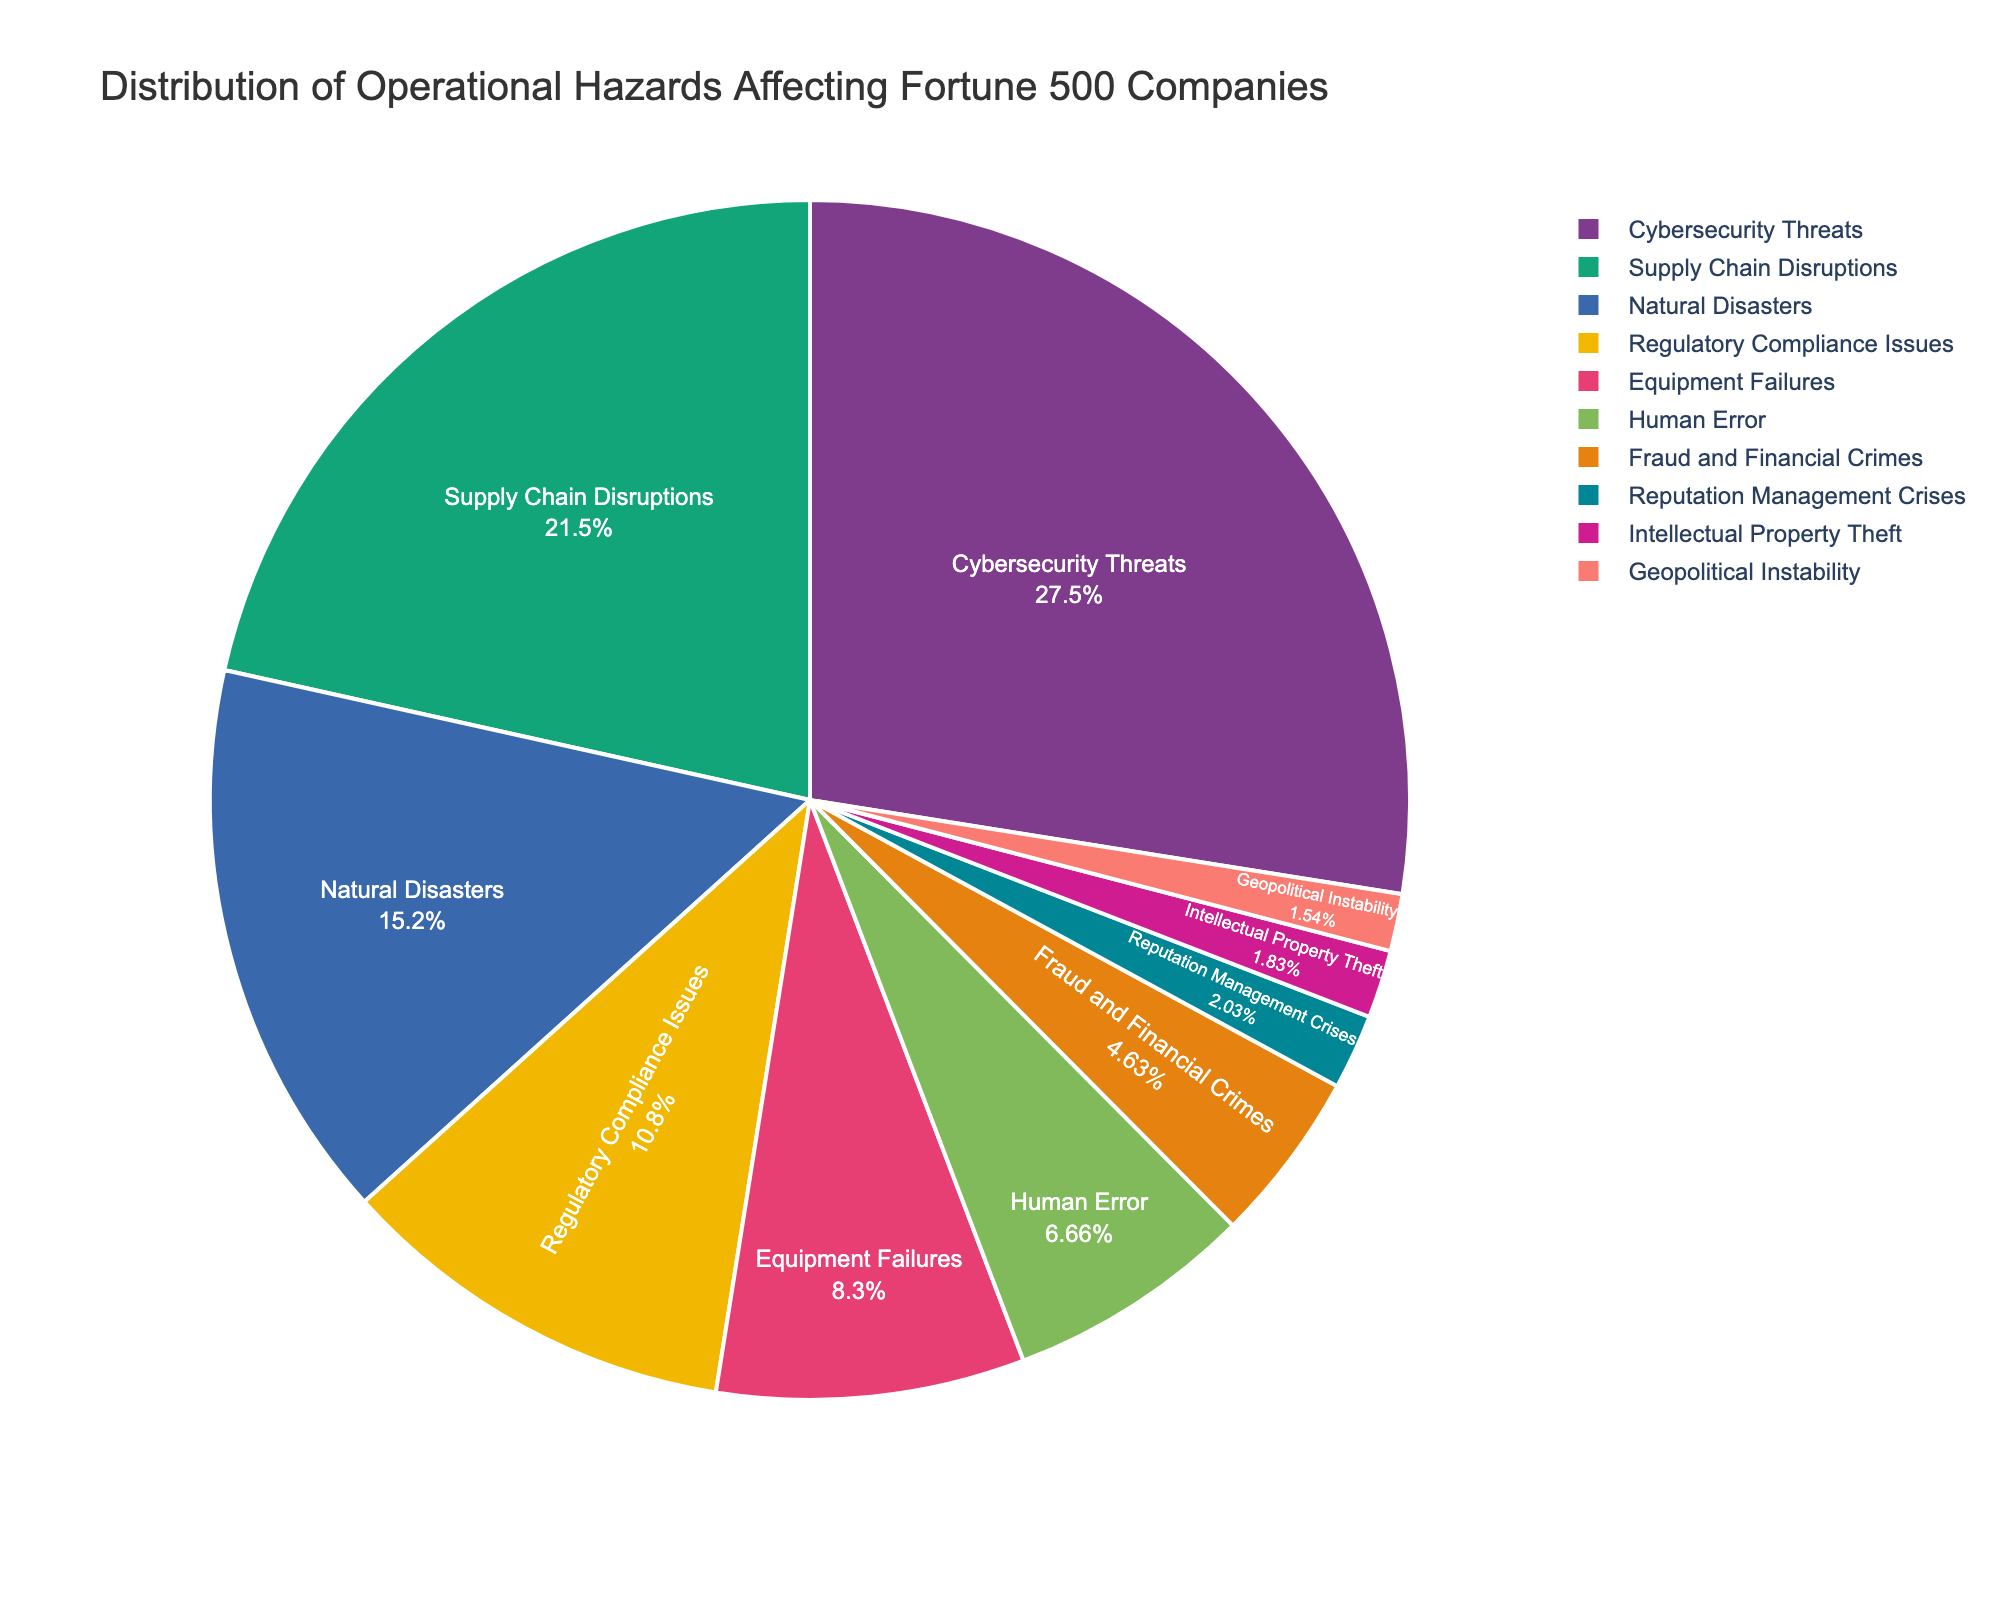What's the largest category of operational hazards? The largest category is the one with the highest percentage. According to the data, Cybersecurity Threats have the highest percentage at 28.5%.
Answer: Cybersecurity Threats Which two categories combined account for nearly half of the operational hazards? To find the categories that combined account for nearly half, we sum the percentages of the two largest categories: Cybersecurity Threats (28.5%) and Supply Chain Disruptions (22.3%). Their sum is 28.5% + 22.3% = 50.8%, which is more than half.
Answer: Cybersecurity Threats and Supply Chain Disruptions What is the percentage difference between Cybersecurity Threats and Natural Disasters? The percentage for Cybersecurity Threats is 28.5% and for Natural Disasters is 15.7%. The difference is calculated as 28.5% - 15.7% = 12.8%.
Answer: 12.8% Which category is visually the smallest on the pie chart, and what is its percentage? The smallest slice in the pie chart corresponds to the category with the smallest percentage. Geopolitical Instability has the smallest percentage at 1.6%.
Answer: Geopolitical Instability, 1.6% Between Equipment Failures and Human Error, which has a higher percentage and by how much? Equipment Failures has a percentage of 8.6% while Human Error has 6.9%. The difference is calculated as 8.6% - 6.9% = 1.7%.
Answer: Equipment Failures, 1.7% What is the combined percentage of the three least significant operational hazards? The three least significant categories are Geopolitical Instability (1.6%), Intellectual Property Theft (1.9%), and Reputation Management Crises (2.1%). The combined percentage is calculated as 1.6% + 1.9% + 2.1% = 5.6%.
Answer: 5.6% How does the percentage of Regulatory Compliance Issues compare to Equipment Failures? Regulatory Compliance Issues have a percentage of 11.2% while Equipment Failures have 8.6%. Regulatory Compliance Issues are greater.
Answer: Regulatory Compliance Issues are greater Are the sum of percentages for Fraud and Financial Crimes and Reputation Management Crises greater than Supply Chain Disruptions? Fraud and Financial Crimes are 4.8% and Reputation Management Crises are 2.1%. Their combined total is 4.8% + 2.1% = 6.9%, which is less than 22.3% for Supply Chain Disruptions.
Answer: No What is the average percentage of Natural Disasters, Human Error, and Regulatory Compliance Issues? Their percentages are Natural Disasters (15.7%), Human Error (6.9%), and Regulatory Compliance Issues (11.2%). The sum is 15.7% + 6.9% + 11.2% = 33.8%. The average is 33.8% / 3 ≈ 11.27%.
Answer: 11.27% 